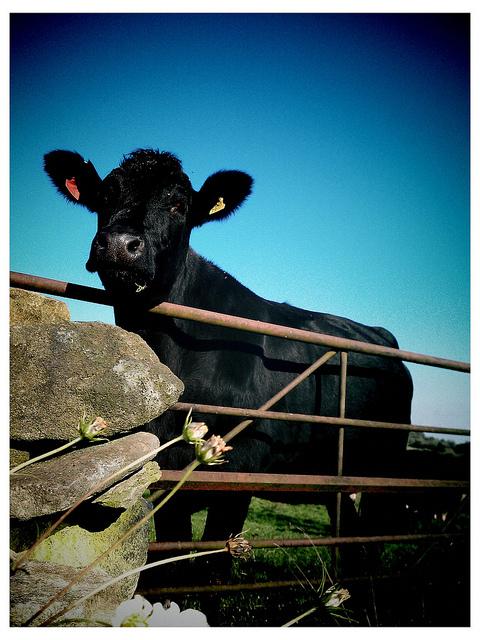Does the cow have tags in both ears?
Be succinct. Yes. Is the cow all black?
Short answer required. Yes. Does this cow belong to someone?
Be succinct. Yes. 